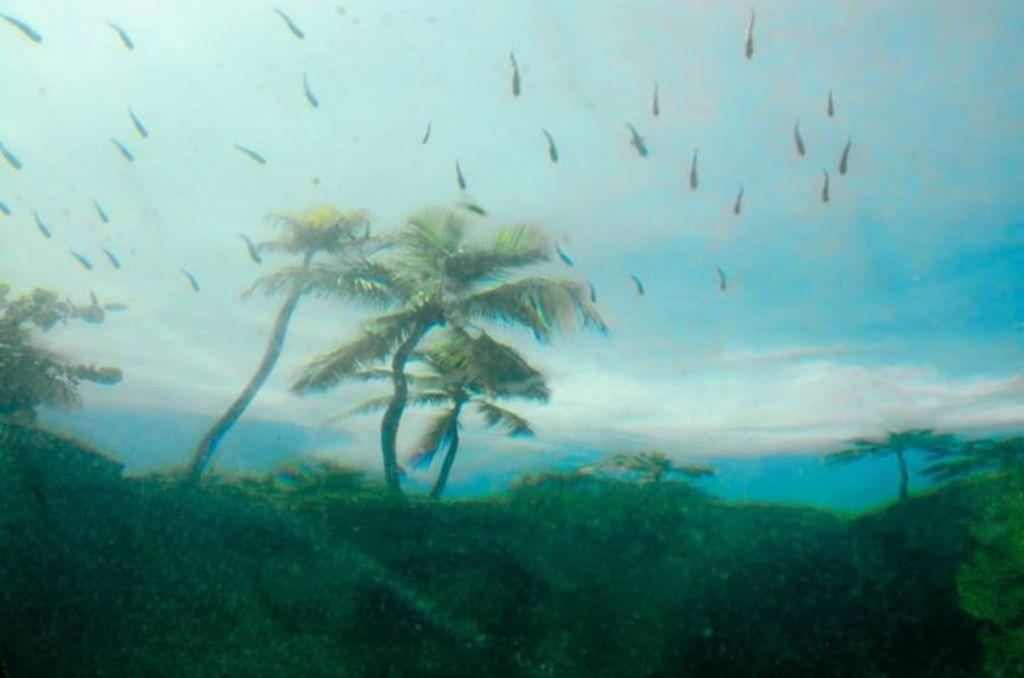What is featured on the poster in the image? There is a poster in the image that contains many trees and depicts hills. What else can be seen in the sky in the image? Birds are flying in the sky in the image. What type of meat can be seen hanging from the trees on the poster? There is no meat present on the poster; it features trees and hills. Are there any snails visible on the hills in the image? There are no snails visible in the image; the hills are depicted without any animals or creatures. 